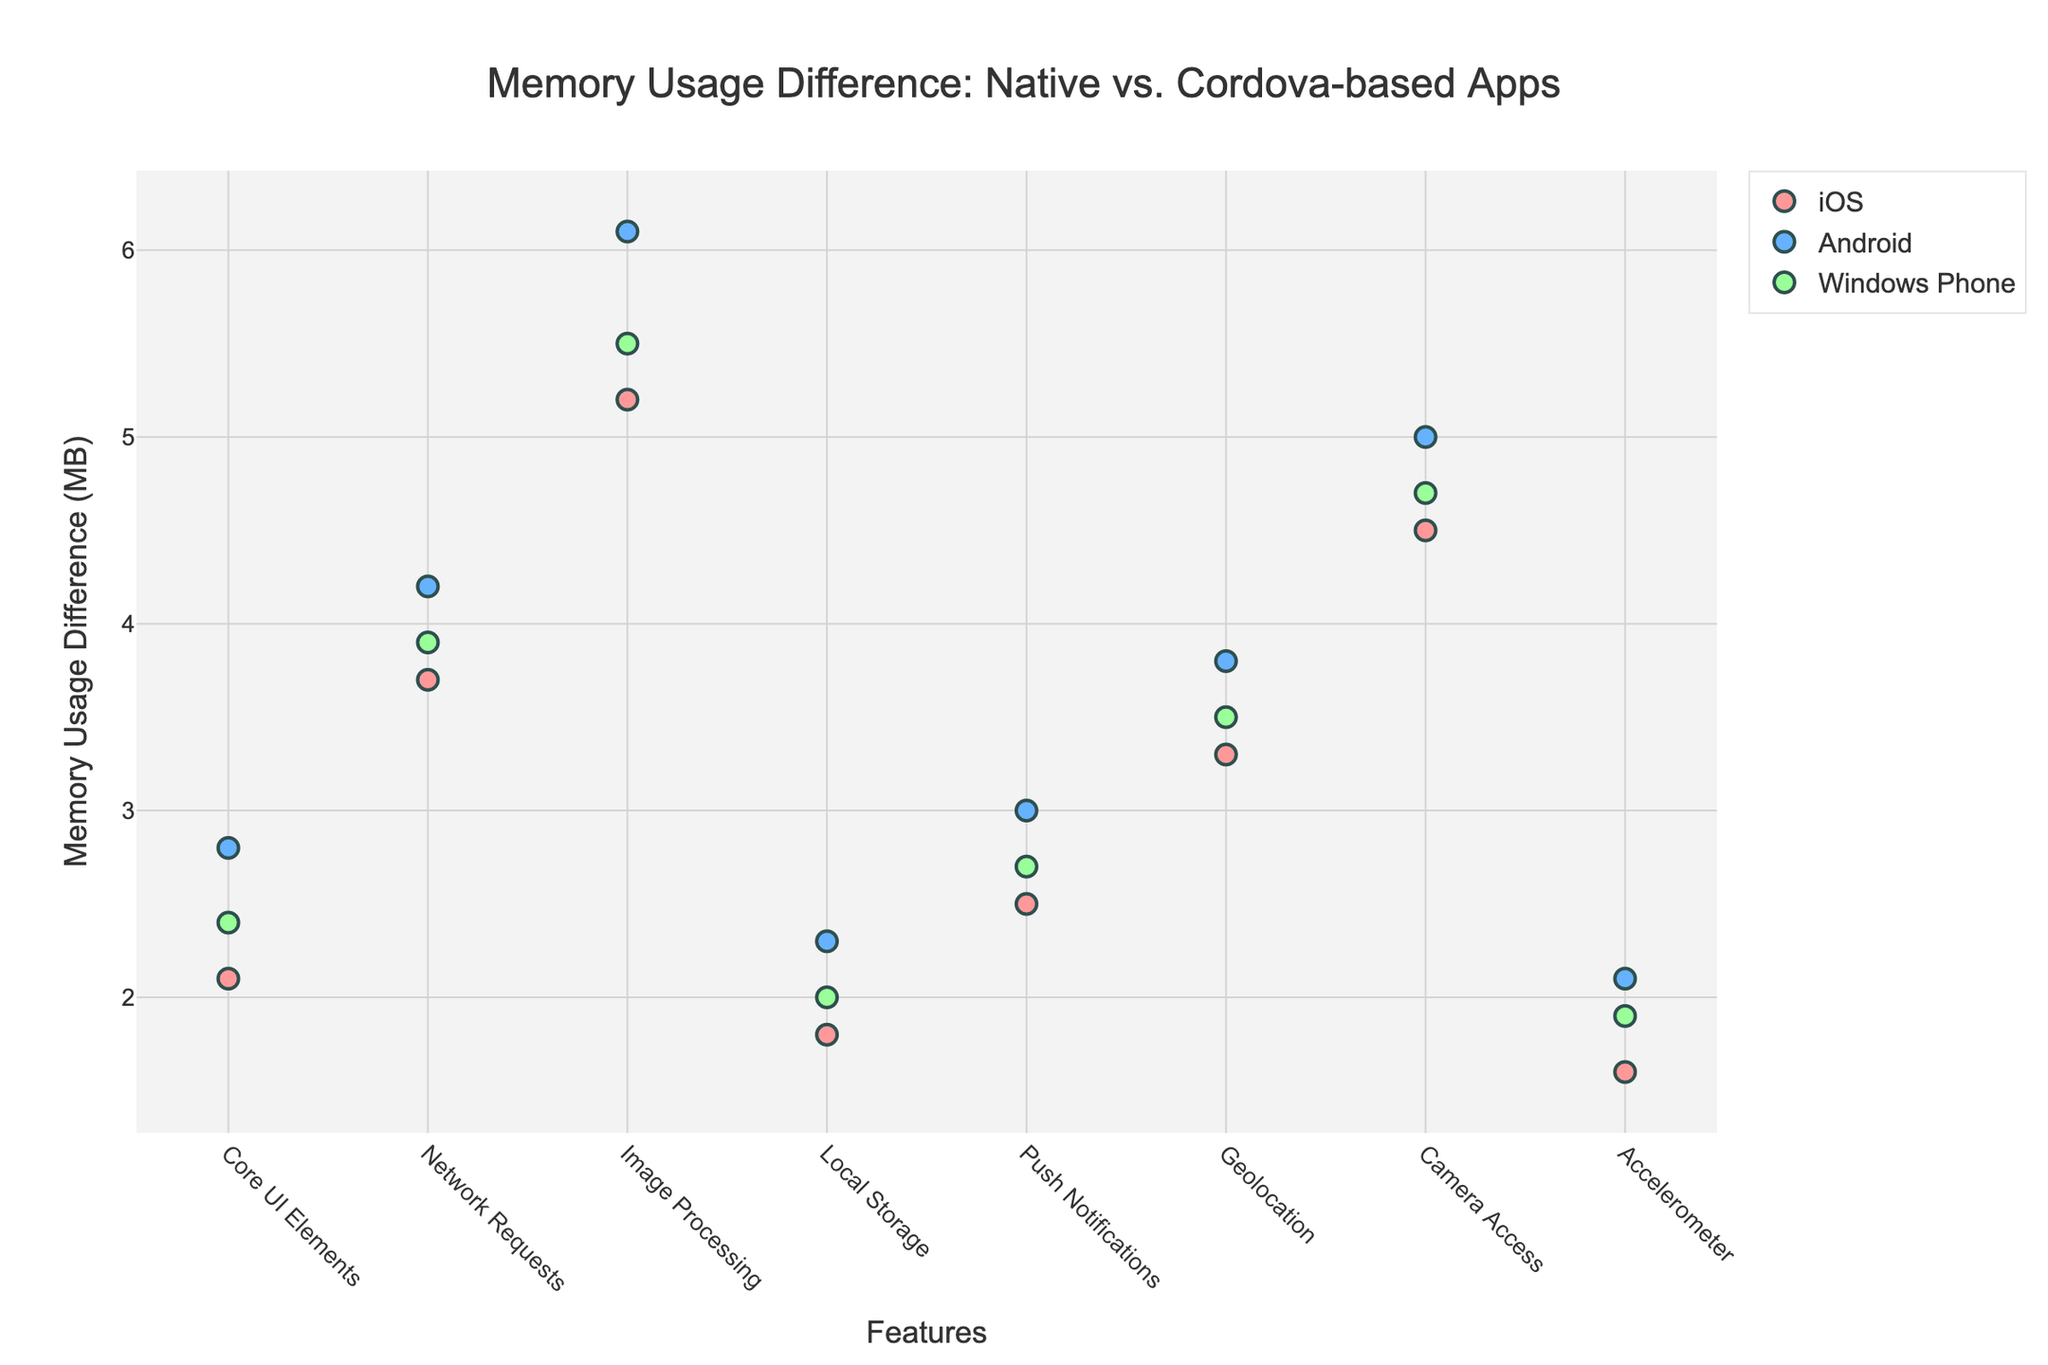What's the title of the plot? The title of the plot is typically displayed at the top and prominently marked to convey the main message. In this case, the title is specified as: "Memory Usage Difference: Native vs. Cordova-based Apps"
Answer: Memory Usage Difference: Native vs. Cordova-based Apps What is the y-axis label? The y-axis label provides information about the vertical axis, which in this case represents the measured variable, defined as "Memory Usage Difference (MB)".
Answer: Memory Usage Difference (MB) Which platform shows the highest memory usage difference for Image Processing? To determine this, locate the 'Image Processing' feature on the x-axis, then identify which platform's data point is the highest. The highest data point for Image Processing across all platforms is for Android, at 6.1 MB.
Answer: Android Which feature on iOS shows the lowest memory usage difference? To find this, identify all the data points for the iOS platform and determine which has the smallest value on the y-axis. The lowest memory usage difference for iOS is 'Accelerometer' at 1.6 MB.
Answer: Accelerometer What feature shows the smallest memory usage difference across all platforms? Identify the smallest y-values across all data points for each feature. The smallest memory usage difference across all platforms is 'Accelerometer' for iOS at 1.6 MB.
Answer: Accelerometer How does the memory usage difference in Network Requests compare between Android and Windows Phone? Compare the y-values of the 'Network Requests' feature for both Android (4.2 MB) and Windows Phone (3.9 MB). Android has a higher memory usage difference than Windows Phone.
Answer: Android is higher What is the average memory usage difference for Geolocation across all platforms? Find the memory usage differences for 'Geolocation' on all platforms (iOS: 3.3 MB, Android: 3.8 MB, Windows Phone: 3.5 MB), sum these differences and then divide by the number of data points (3). (3.3 + 3.8 + 3.5) / 3 = 3.53 MB.
Answer: 3.53 MB Which platform shows the largest variability in memory usage difference across features? To determine the platform with the largest variability, observe the range of y-values for each platform. Android ranges from 2.1 MB to 6.1 MB, displaying the largest variability.
Answer: Android What is the difference in memory usage for Push Notifications between iOS and Windows Phone? Identify the y-values for 'Push Notifications' for both iOS (2.5 MB) and Windows Phone (2.7 MB). The difference is 2.7 - 2.5 = 0.2 MB.
Answer: 0.2 MB What is the total memory usage difference for all features on Android? Sum the memory usage differences for all features on Android (2.8 + 4.2 + 6.1 + 2.3 + 3.0 + 3.8 + 5.0 + 2.1). The total is 29.3 MB.
Answer: 29.3 MB What is the median memory usage difference for the iOS platform? First, list the memory usage differences for all features on iOS in ascending order: 1.6, 1.8, 2.1, 2.5, 3.3, 3.7, 4.5, 5.2. The median value is the average of the 4th and 5th values: (2.5 + 3.3) / 2 = 2.9 MB.
Answer: 2.9 MB 